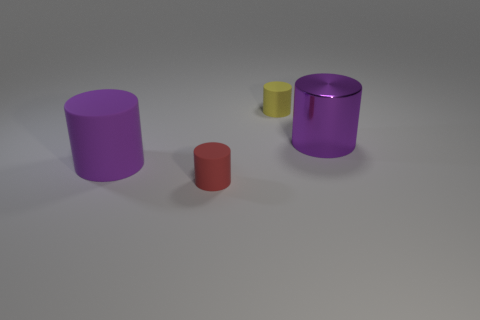Can you describe the different sizes of cylinders in the image? Certainly, there are four cylinders of varying sizes. From left to right, there's a large purple cylinder, a medium purple cylinder, a small yellow cylinder, and a large violet cylinder with a reflective surface. Do the cylinders seem to serve a specific purpose? There's no clear indication of a specific purpose given the image alone. They appear to be simple geometric shapes perhaps used in a visualization, artistic composition, or for staging a scene for a photograph. 